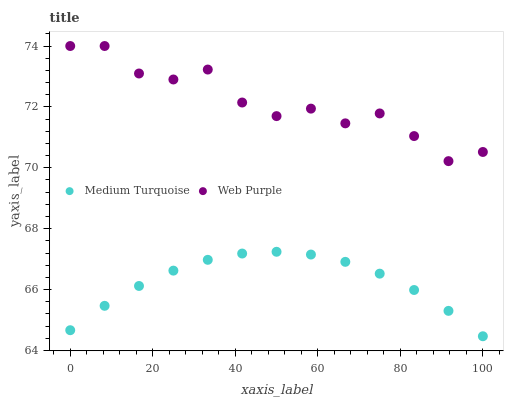Does Medium Turquoise have the minimum area under the curve?
Answer yes or no. Yes. Does Web Purple have the maximum area under the curve?
Answer yes or no. Yes. Does Medium Turquoise have the maximum area under the curve?
Answer yes or no. No. Is Medium Turquoise the smoothest?
Answer yes or no. Yes. Is Web Purple the roughest?
Answer yes or no. Yes. Is Medium Turquoise the roughest?
Answer yes or no. No. Does Medium Turquoise have the lowest value?
Answer yes or no. Yes. Does Web Purple have the highest value?
Answer yes or no. Yes. Does Medium Turquoise have the highest value?
Answer yes or no. No. Is Medium Turquoise less than Web Purple?
Answer yes or no. Yes. Is Web Purple greater than Medium Turquoise?
Answer yes or no. Yes. Does Medium Turquoise intersect Web Purple?
Answer yes or no. No. 